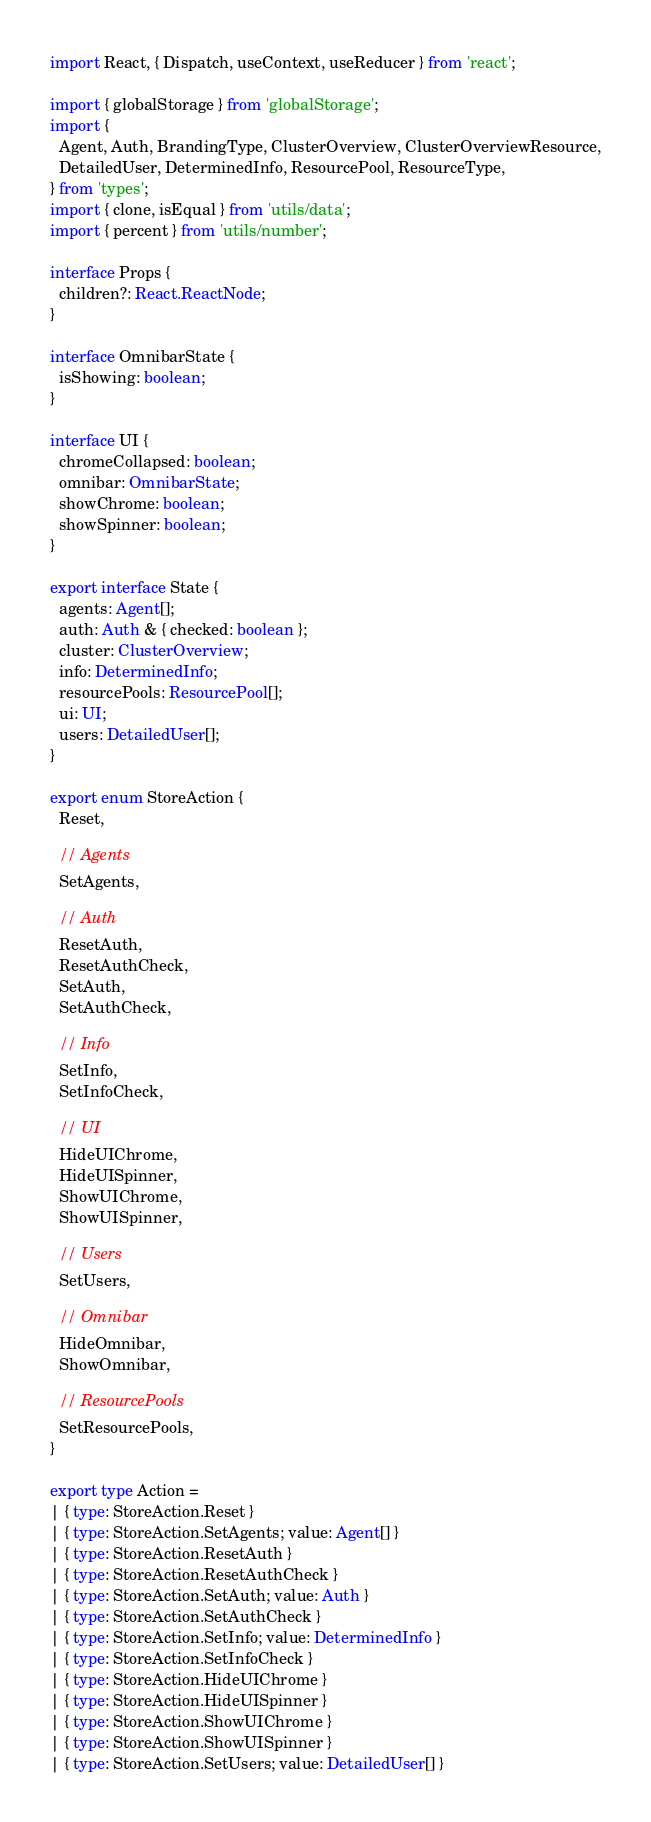Convert code to text. <code><loc_0><loc_0><loc_500><loc_500><_TypeScript_>import React, { Dispatch, useContext, useReducer } from 'react';

import { globalStorage } from 'globalStorage';
import {
  Agent, Auth, BrandingType, ClusterOverview, ClusterOverviewResource,
  DetailedUser, DeterminedInfo, ResourcePool, ResourceType,
} from 'types';
import { clone, isEqual } from 'utils/data';
import { percent } from 'utils/number';

interface Props {
  children?: React.ReactNode;
}

interface OmnibarState {
  isShowing: boolean;
}

interface UI {
  chromeCollapsed: boolean;
  omnibar: OmnibarState;
  showChrome: boolean;
  showSpinner: boolean;
}

export interface State {
  agents: Agent[];
  auth: Auth & { checked: boolean };
  cluster: ClusterOverview;
  info: DeterminedInfo;
  resourcePools: ResourcePool[];
  ui: UI;
  users: DetailedUser[];
}

export enum StoreAction {
  Reset,

  // Agents
  SetAgents,

  // Auth
  ResetAuth,
  ResetAuthCheck,
  SetAuth,
  SetAuthCheck,

  // Info
  SetInfo,
  SetInfoCheck,

  // UI
  HideUIChrome,
  HideUISpinner,
  ShowUIChrome,
  ShowUISpinner,

  // Users
  SetUsers,

  // Omnibar
  HideOmnibar,
  ShowOmnibar,

  // ResourcePools
  SetResourcePools,
}

export type Action =
| { type: StoreAction.Reset }
| { type: StoreAction.SetAgents; value: Agent[] }
| { type: StoreAction.ResetAuth }
| { type: StoreAction.ResetAuthCheck }
| { type: StoreAction.SetAuth; value: Auth }
| { type: StoreAction.SetAuthCheck }
| { type: StoreAction.SetInfo; value: DeterminedInfo }
| { type: StoreAction.SetInfoCheck }
| { type: StoreAction.HideUIChrome }
| { type: StoreAction.HideUISpinner }
| { type: StoreAction.ShowUIChrome }
| { type: StoreAction.ShowUISpinner }
| { type: StoreAction.SetUsers; value: DetailedUser[] }</code> 